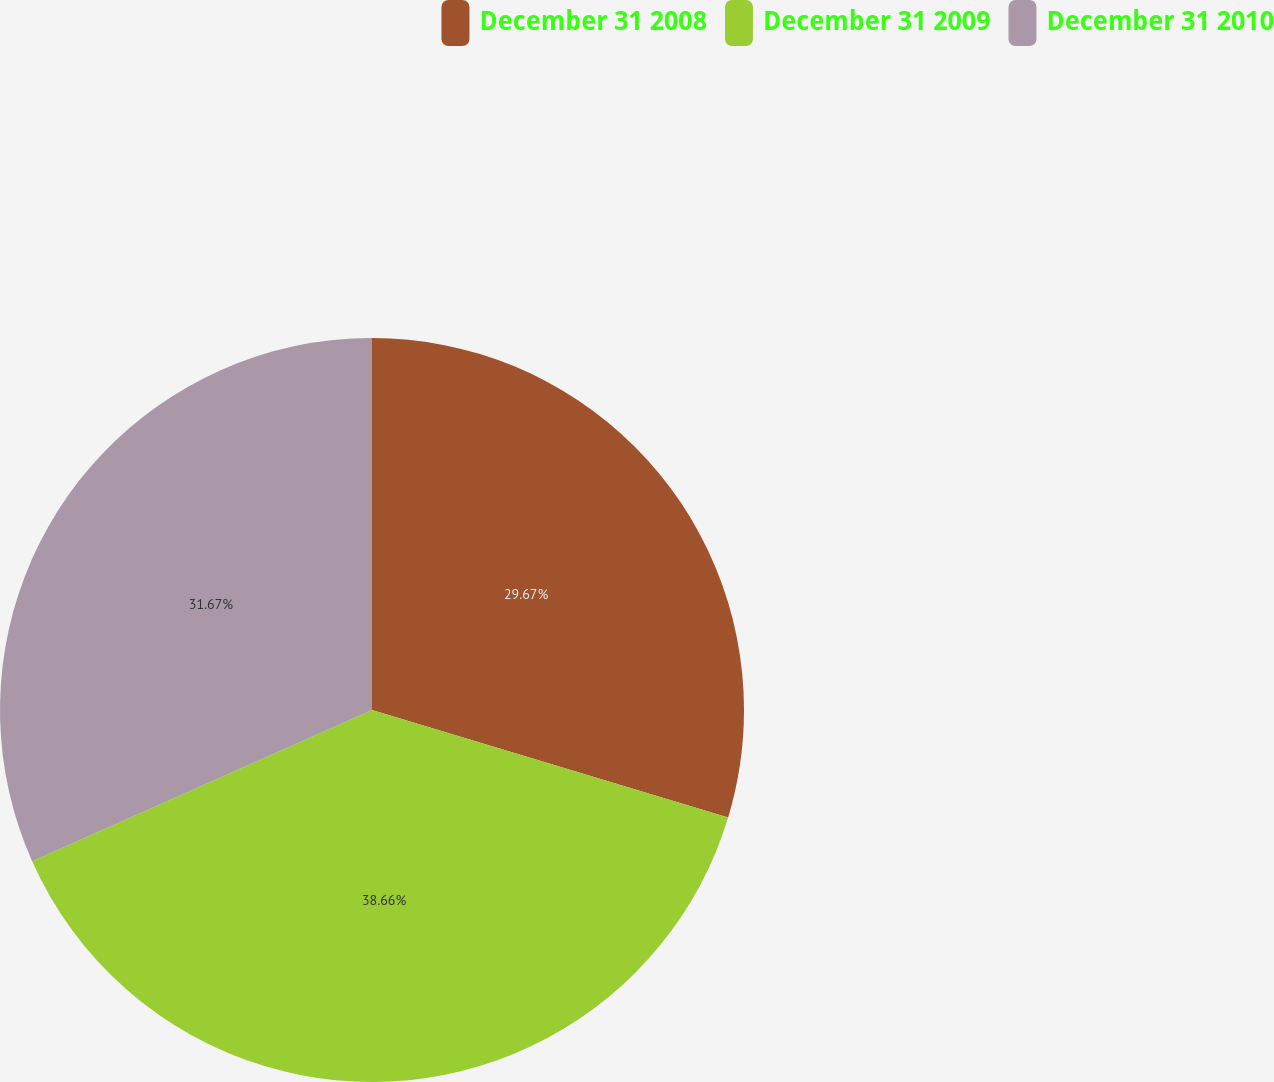Convert chart to OTSL. <chart><loc_0><loc_0><loc_500><loc_500><pie_chart><fcel>December 31 2008<fcel>December 31 2009<fcel>December 31 2010<nl><fcel>29.67%<fcel>38.67%<fcel>31.67%<nl></chart> 